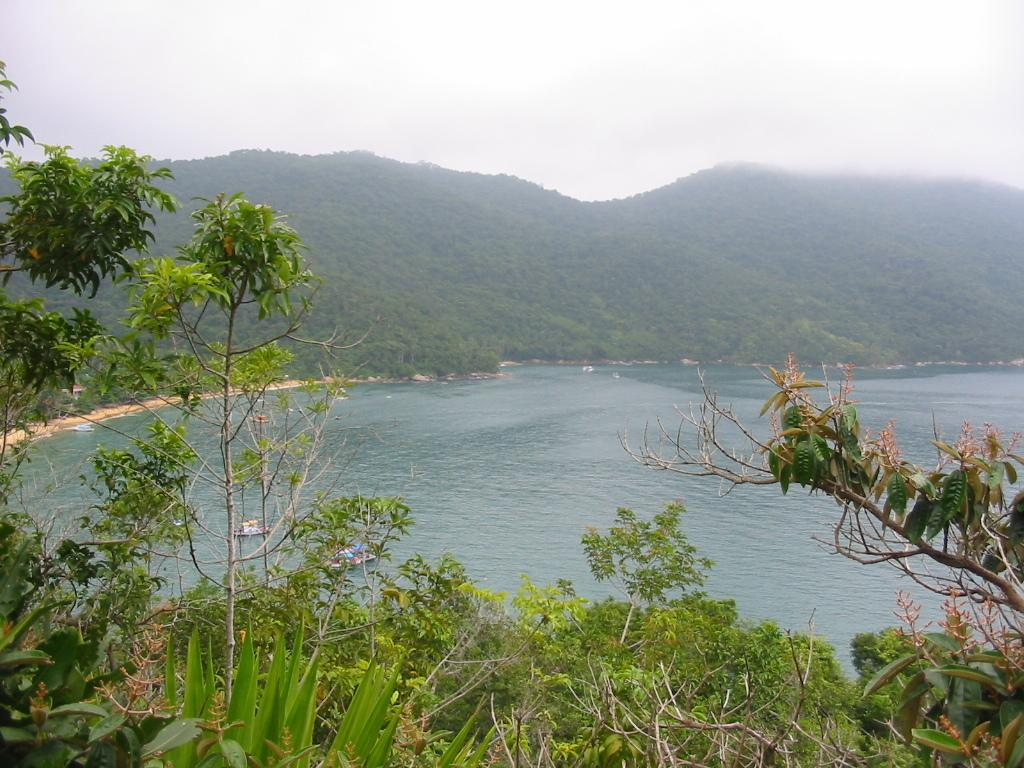What type of vegetation can be seen on the hills in the image? There are trees on the hills in the image. What can be seen in the water in the image? There are boats in the water in the image. What is the condition of the sky in the image? The sky is cloudy in the image. What type of wine is being served on the boats in the image? There is no wine present in the image; it features boats in the water and trees on the hills. How many sheep can be seen grazing on the hills in the image? There are no sheep present in the image; it only features trees on the hills. 